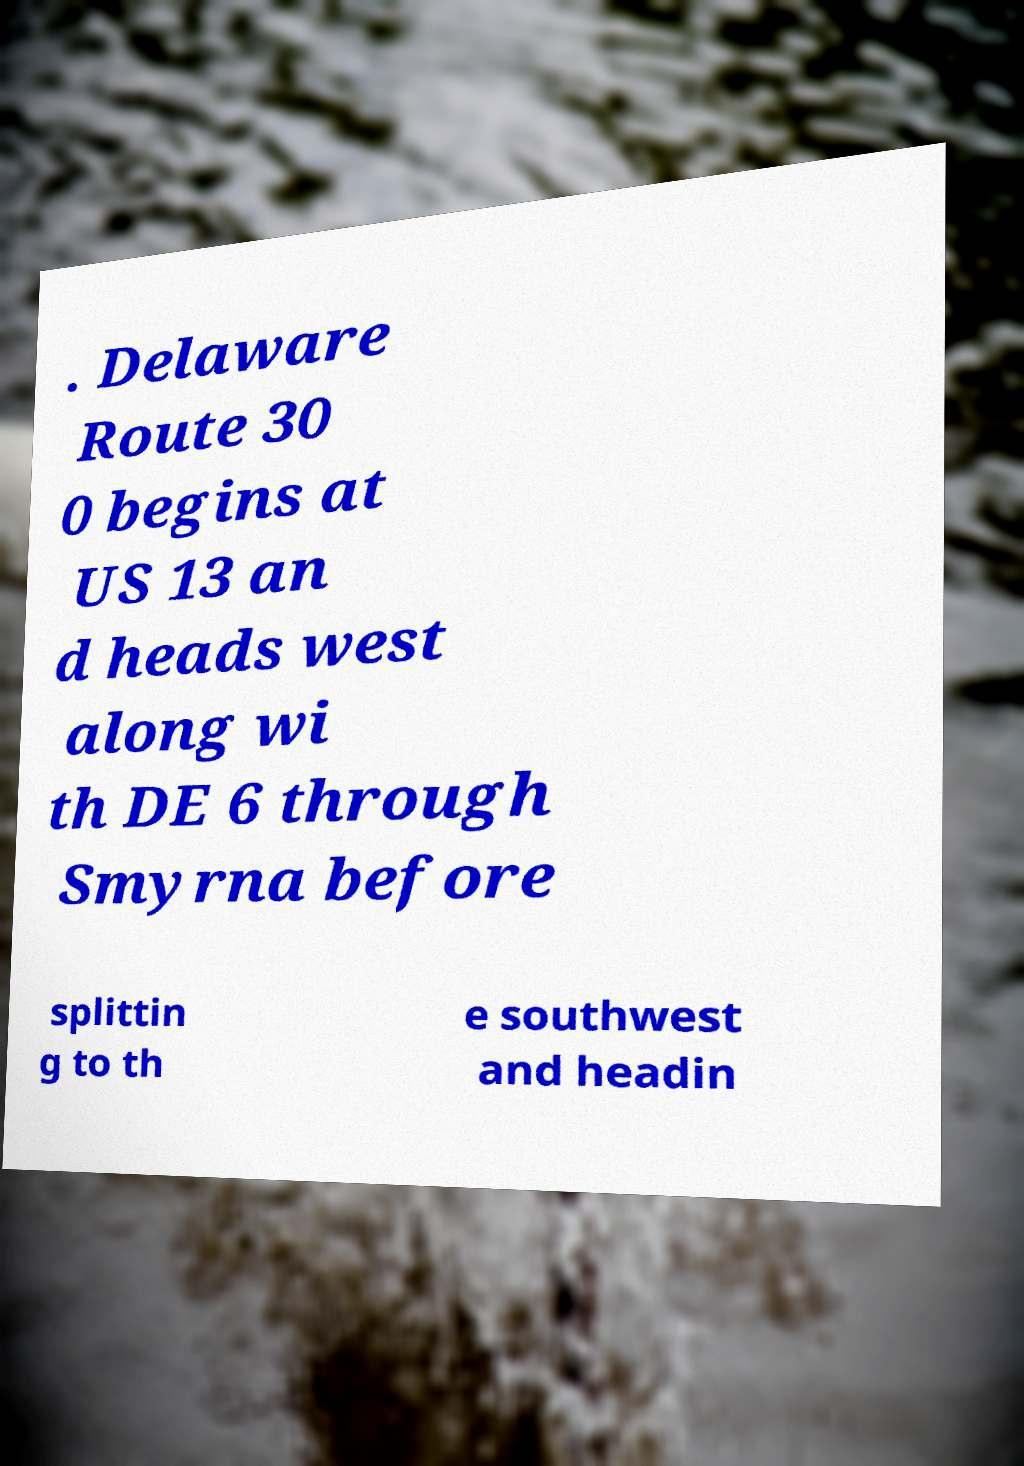Can you read and provide the text displayed in the image?This photo seems to have some interesting text. Can you extract and type it out for me? . Delaware Route 30 0 begins at US 13 an d heads west along wi th DE 6 through Smyrna before splittin g to th e southwest and headin 